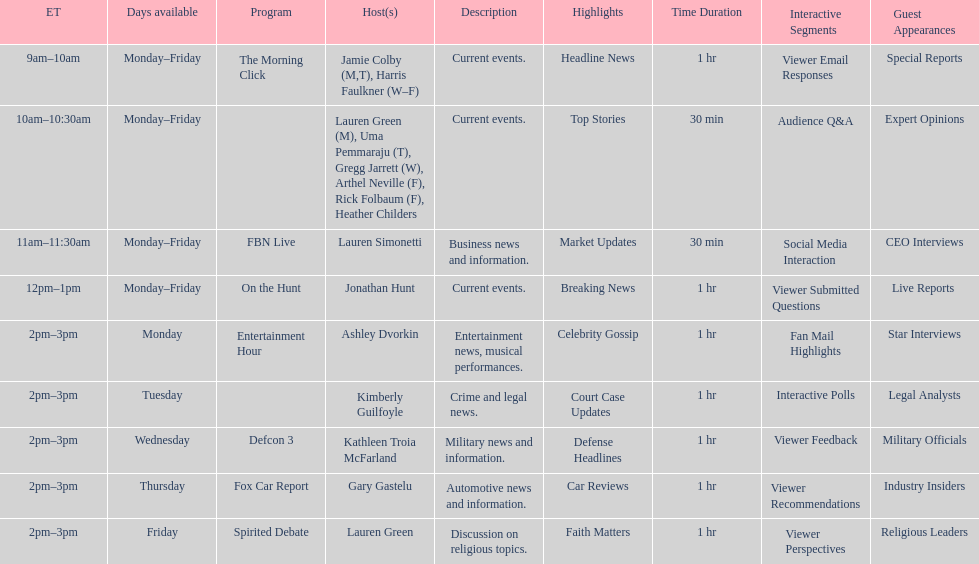What is the count of programs that feature a single host daily? 7. 